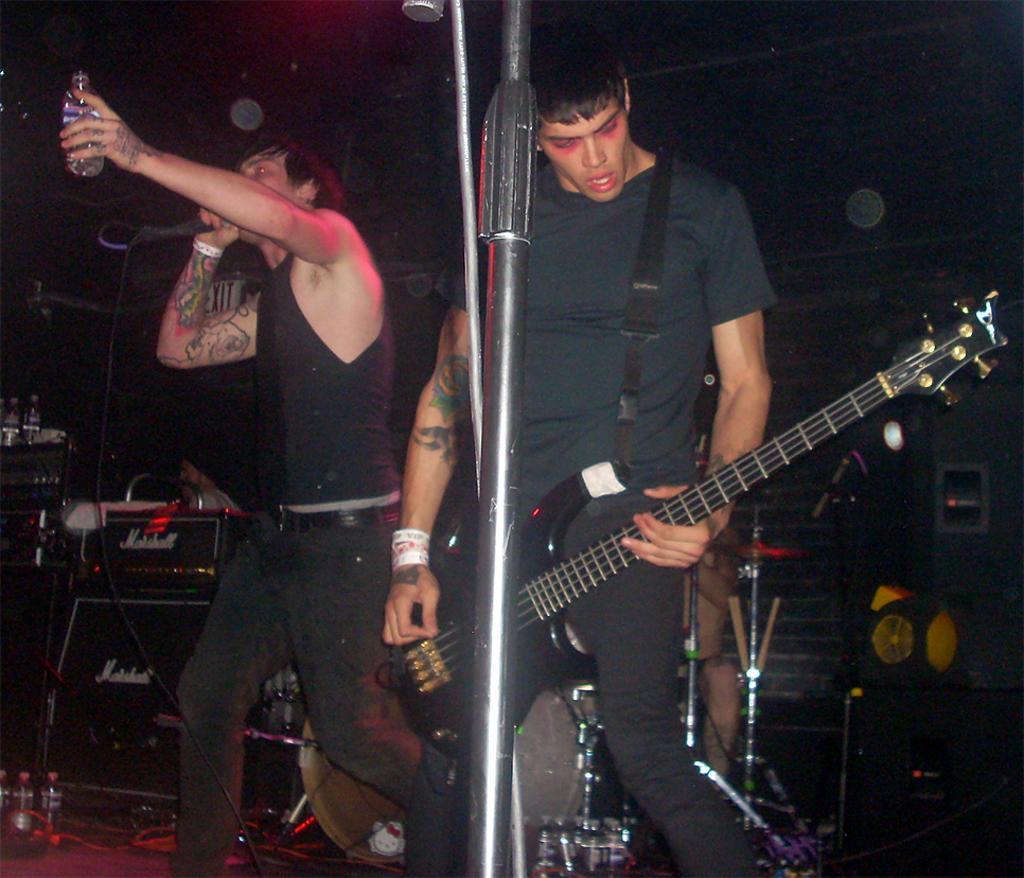Can you describe this image briefly? As we can see in the image there are two people. The man on the right side is holding guitar and the man on the left side is singing a song on mic and holding bottle. 